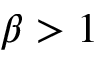Convert formula to latex. <formula><loc_0><loc_0><loc_500><loc_500>\beta > 1</formula> 